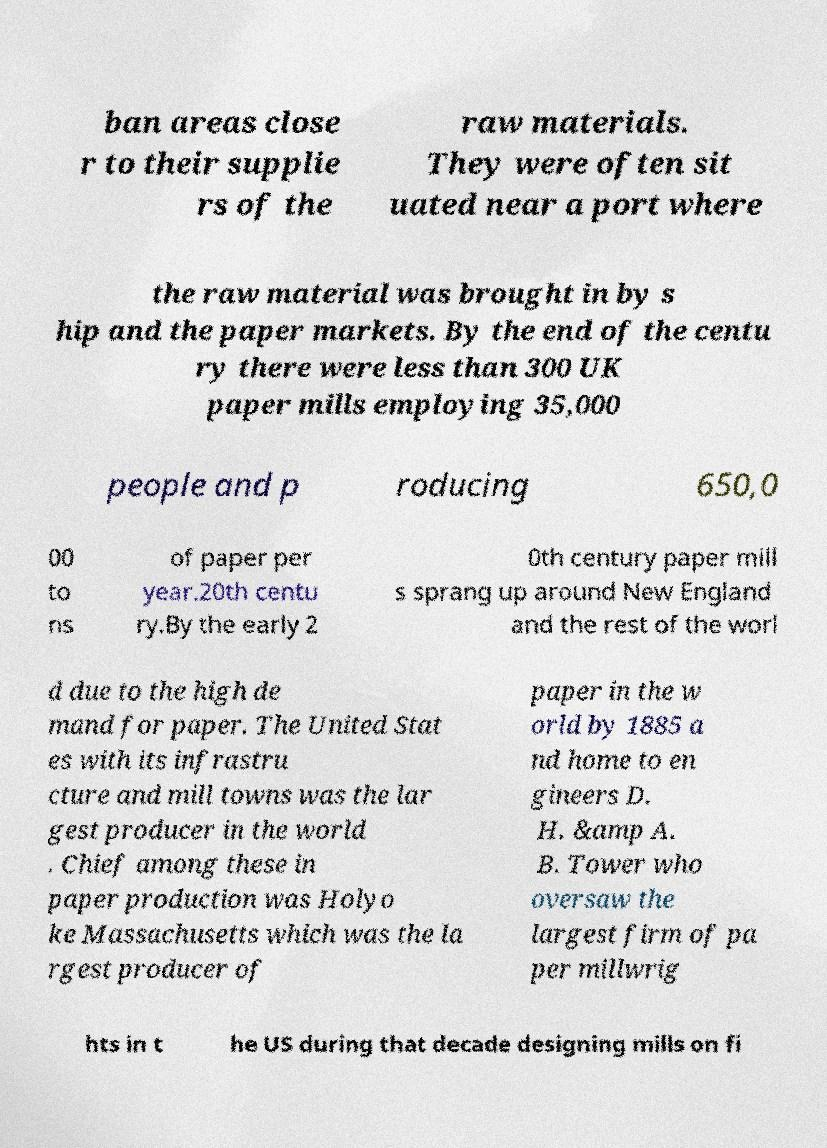Can you accurately transcribe the text from the provided image for me? ban areas close r to their supplie rs of the raw materials. They were often sit uated near a port where the raw material was brought in by s hip and the paper markets. By the end of the centu ry there were less than 300 UK paper mills employing 35,000 people and p roducing 650,0 00 to ns of paper per year.20th centu ry.By the early 2 0th century paper mill s sprang up around New England and the rest of the worl d due to the high de mand for paper. The United Stat es with its infrastru cture and mill towns was the lar gest producer in the world . Chief among these in paper production was Holyo ke Massachusetts which was the la rgest producer of paper in the w orld by 1885 a nd home to en gineers D. H. &amp A. B. Tower who oversaw the largest firm of pa per millwrig hts in t he US during that decade designing mills on fi 